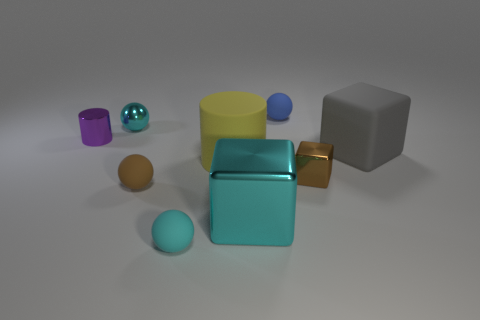There is a big gray object that is the same shape as the tiny brown metal thing; what material is it?
Keep it short and to the point. Rubber. What size is the cylinder left of the tiny cyan shiny thing left of the blue matte object?
Provide a succinct answer. Small. Are any tiny cyan rubber objects visible?
Offer a terse response. Yes. What material is the big object that is both on the left side of the tiny brown cube and behind the brown shiny cube?
Offer a terse response. Rubber. Are there more small metal balls in front of the tiny cyan matte thing than brown matte things that are on the right side of the tiny blue matte ball?
Offer a terse response. No. Are there any yellow rubber things of the same size as the gray rubber object?
Provide a short and direct response. Yes. How big is the cyan sphere that is in front of the tiny brown thing that is left of the small rubber ball to the right of the large rubber cylinder?
Make the answer very short. Small. The large cylinder has what color?
Offer a terse response. Yellow. Are there more yellow cylinders to the left of the brown metallic object than purple objects?
Offer a terse response. No. There is a small purple cylinder; how many cubes are behind it?
Provide a short and direct response. 0. 